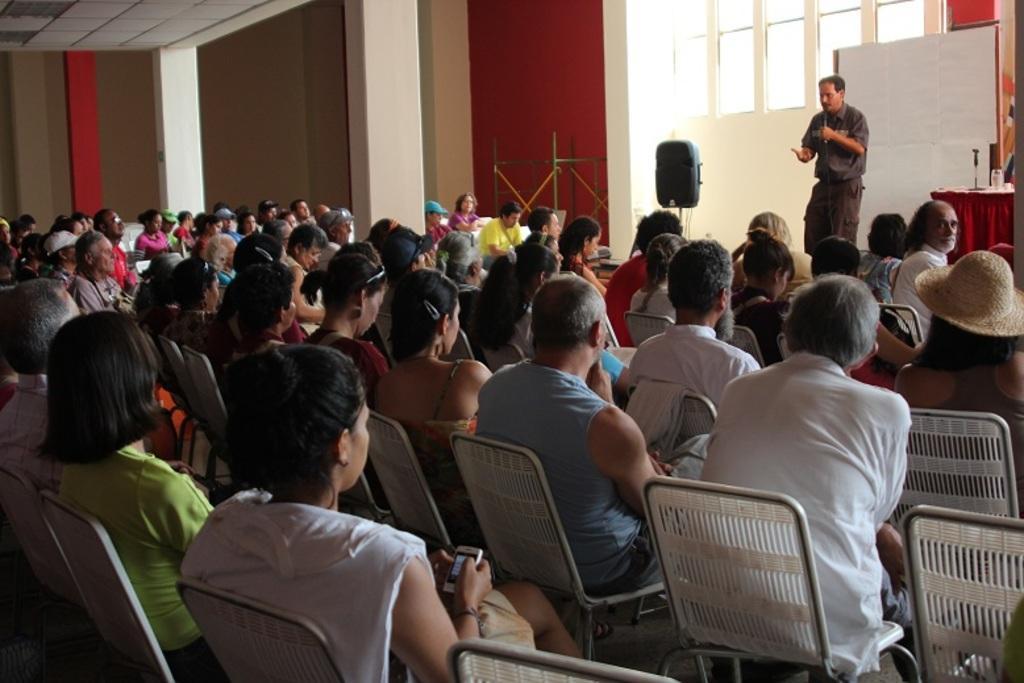Please provide a concise description of this image. In this picture we can see a group of people are sitting on the chairs. At the bottom of the image we can see a lady is holding a mobile. In the background of the image we can see the wall, pillars, rods, windows, speaker, board, table and a man is standing and holding a mic and talking. On the table we can see a cloth, glass and some other objects. In the top left corner we can see the roof. 